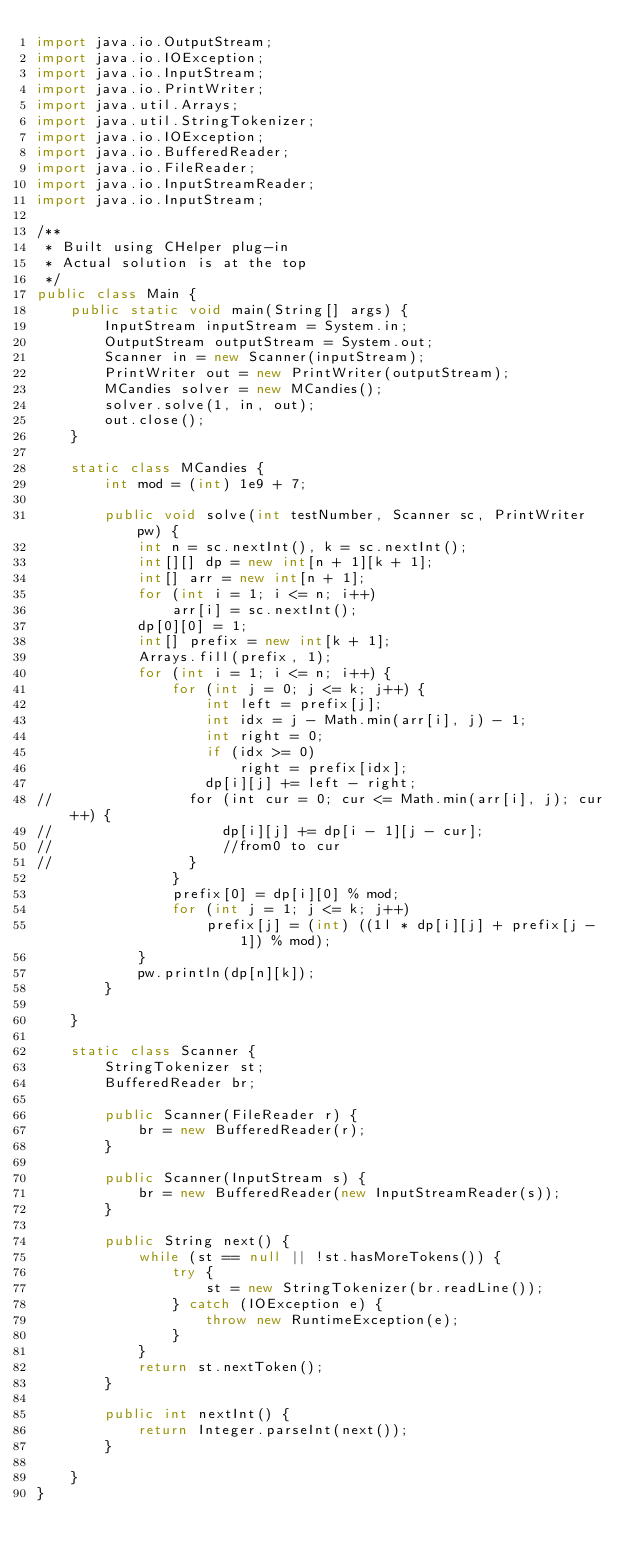Convert code to text. <code><loc_0><loc_0><loc_500><loc_500><_Java_>import java.io.OutputStream;
import java.io.IOException;
import java.io.InputStream;
import java.io.PrintWriter;
import java.util.Arrays;
import java.util.StringTokenizer;
import java.io.IOException;
import java.io.BufferedReader;
import java.io.FileReader;
import java.io.InputStreamReader;
import java.io.InputStream;

/**
 * Built using CHelper plug-in
 * Actual solution is at the top
 */
public class Main {
    public static void main(String[] args) {
        InputStream inputStream = System.in;
        OutputStream outputStream = System.out;
        Scanner in = new Scanner(inputStream);
        PrintWriter out = new PrintWriter(outputStream);
        MCandies solver = new MCandies();
        solver.solve(1, in, out);
        out.close();
    }

    static class MCandies {
        int mod = (int) 1e9 + 7;

        public void solve(int testNumber, Scanner sc, PrintWriter pw) {
            int n = sc.nextInt(), k = sc.nextInt();
            int[][] dp = new int[n + 1][k + 1];
            int[] arr = new int[n + 1];
            for (int i = 1; i <= n; i++)
                arr[i] = sc.nextInt();
            dp[0][0] = 1;
            int[] prefix = new int[k + 1];
            Arrays.fill(prefix, 1);
            for (int i = 1; i <= n; i++) {
                for (int j = 0; j <= k; j++) {
                    int left = prefix[j];
                    int idx = j - Math.min(arr[i], j) - 1;
                    int right = 0;
                    if (idx >= 0)
                        right = prefix[idx];
                    dp[i][j] += left - right;
//                for (int cur = 0; cur <= Math.min(arr[i], j); cur++) {
//                    dp[i][j] += dp[i - 1][j - cur];
//                    //from0 to cur
//                }
                }
                prefix[0] = dp[i][0] % mod;
                for (int j = 1; j <= k; j++)
                    prefix[j] = (int) ((1l * dp[i][j] + prefix[j - 1]) % mod);
            }
            pw.println(dp[n][k]);
        }

    }

    static class Scanner {
        StringTokenizer st;
        BufferedReader br;

        public Scanner(FileReader r) {
            br = new BufferedReader(r);
        }

        public Scanner(InputStream s) {
            br = new BufferedReader(new InputStreamReader(s));
        }

        public String next() {
            while (st == null || !st.hasMoreTokens()) {
                try {
                    st = new StringTokenizer(br.readLine());
                } catch (IOException e) {
                    throw new RuntimeException(e);
                }
            }
            return st.nextToken();
        }

        public int nextInt() {
            return Integer.parseInt(next());
        }

    }
}

</code> 